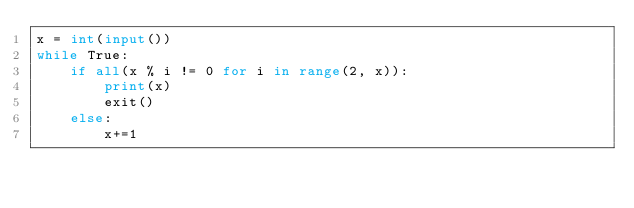Convert code to text. <code><loc_0><loc_0><loc_500><loc_500><_Python_>x = int(input())
while True:
    if all(x % i != 0 for i in range(2, x)):
        print(x)
        exit()
    else:
        x+=1</code> 